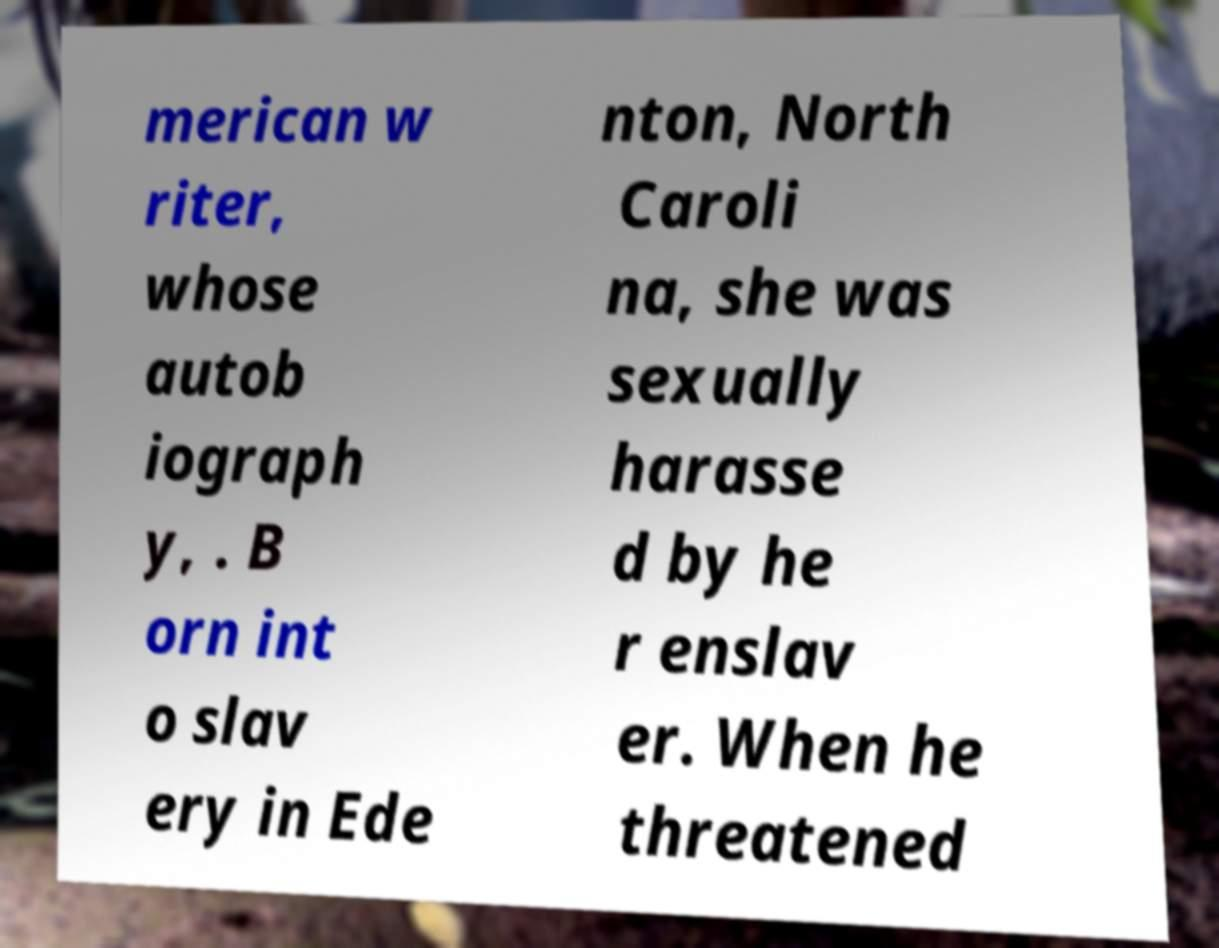There's text embedded in this image that I need extracted. Can you transcribe it verbatim? merican w riter, whose autob iograph y, . B orn int o slav ery in Ede nton, North Caroli na, she was sexually harasse d by he r enslav er. When he threatened 